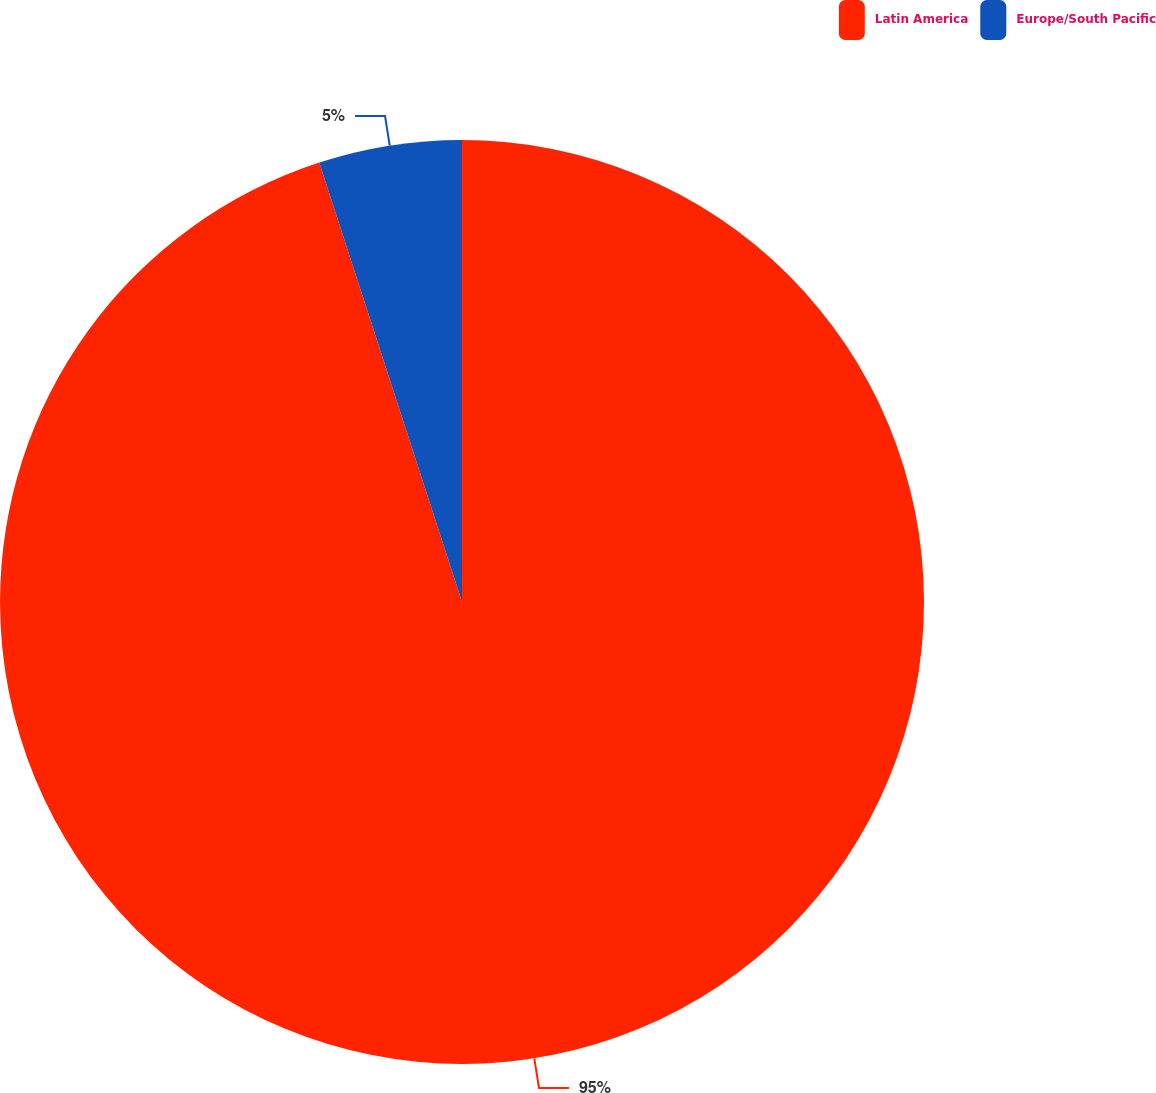<chart> <loc_0><loc_0><loc_500><loc_500><pie_chart><fcel>Latin America<fcel>Europe/South Pacific<nl><fcel>95.0%<fcel>5.0%<nl></chart> 